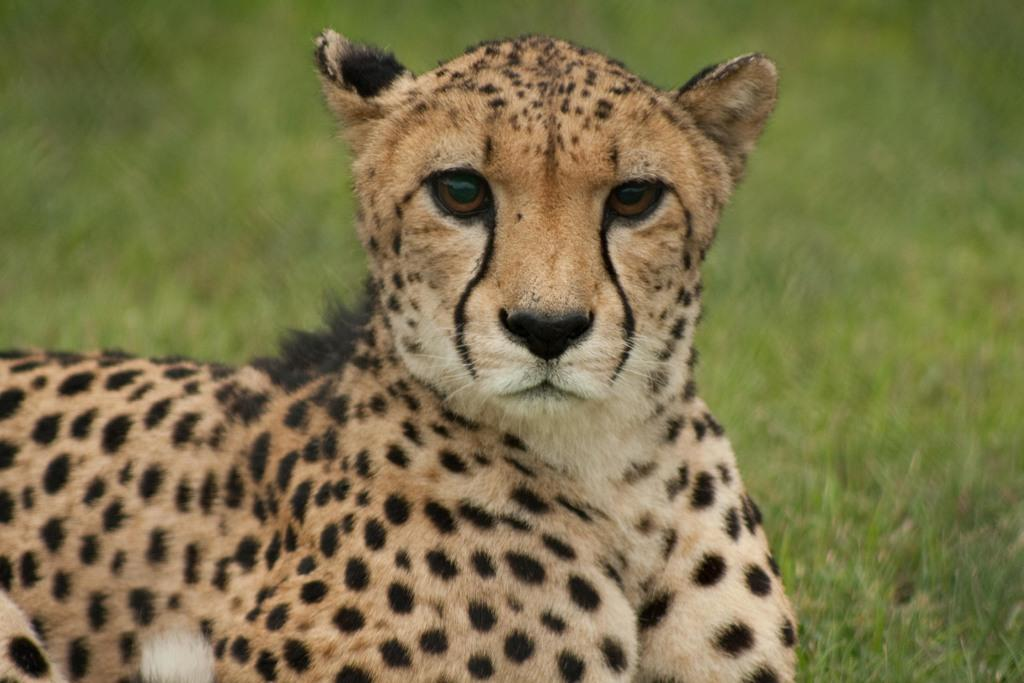What type of animal is in the image? The animal in the image is not specified, but it has brown, white, and black colors. Can you describe the color pattern of the animal? The animal has brown, white, and black colors. What is visible in the background of the image? The background of the image includes grass, but it is blurry. What type of pancake is being served in the image? There is no pancake present in the image; it features an animal with brown, white, and black colors in a blurry grass background. 